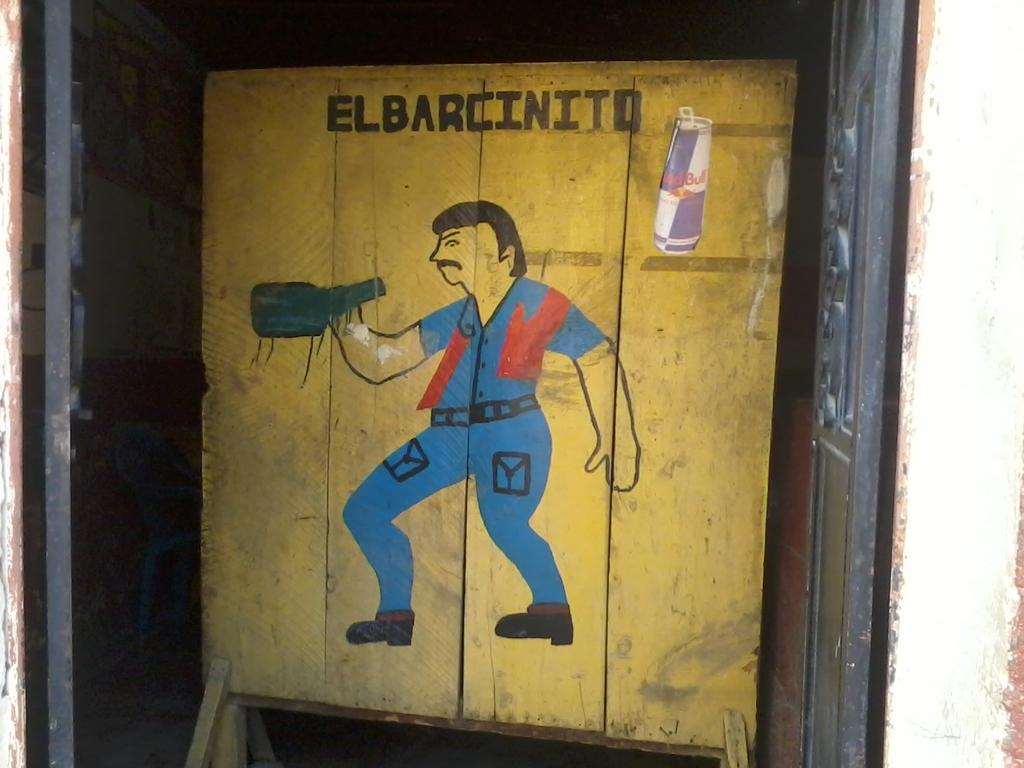<image>
Write a terse but informative summary of the picture. Picture that shows a man holding a bottle of alcohol and the word "Elbarcinito" on top. 